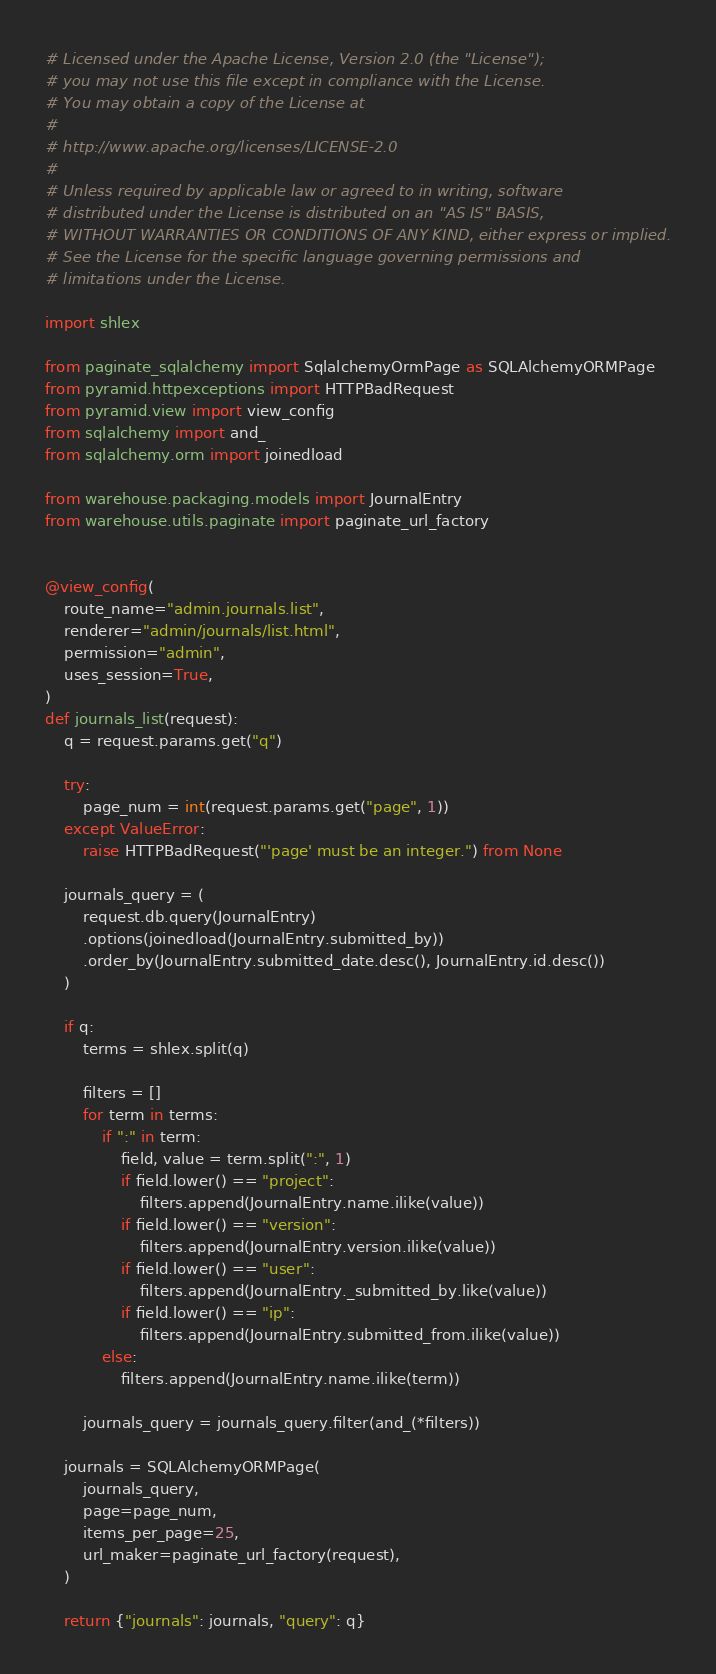<code> <loc_0><loc_0><loc_500><loc_500><_Python_># Licensed under the Apache License, Version 2.0 (the "License");
# you may not use this file except in compliance with the License.
# You may obtain a copy of the License at
#
# http://www.apache.org/licenses/LICENSE-2.0
#
# Unless required by applicable law or agreed to in writing, software
# distributed under the License is distributed on an "AS IS" BASIS,
# WITHOUT WARRANTIES OR CONDITIONS OF ANY KIND, either express or implied.
# See the License for the specific language governing permissions and
# limitations under the License.

import shlex

from paginate_sqlalchemy import SqlalchemyOrmPage as SQLAlchemyORMPage
from pyramid.httpexceptions import HTTPBadRequest
from pyramid.view import view_config
from sqlalchemy import and_
from sqlalchemy.orm import joinedload

from warehouse.packaging.models import JournalEntry
from warehouse.utils.paginate import paginate_url_factory


@view_config(
    route_name="admin.journals.list",
    renderer="admin/journals/list.html",
    permission="admin",
    uses_session=True,
)
def journals_list(request):
    q = request.params.get("q")

    try:
        page_num = int(request.params.get("page", 1))
    except ValueError:
        raise HTTPBadRequest("'page' must be an integer.") from None

    journals_query = (
        request.db.query(JournalEntry)
        .options(joinedload(JournalEntry.submitted_by))
        .order_by(JournalEntry.submitted_date.desc(), JournalEntry.id.desc())
    )

    if q:
        terms = shlex.split(q)

        filters = []
        for term in terms:
            if ":" in term:
                field, value = term.split(":", 1)
                if field.lower() == "project":
                    filters.append(JournalEntry.name.ilike(value))
                if field.lower() == "version":
                    filters.append(JournalEntry.version.ilike(value))
                if field.lower() == "user":
                    filters.append(JournalEntry._submitted_by.like(value))
                if field.lower() == "ip":
                    filters.append(JournalEntry.submitted_from.ilike(value))
            else:
                filters.append(JournalEntry.name.ilike(term))

        journals_query = journals_query.filter(and_(*filters))

    journals = SQLAlchemyORMPage(
        journals_query,
        page=page_num,
        items_per_page=25,
        url_maker=paginate_url_factory(request),
    )

    return {"journals": journals, "query": q}
</code> 